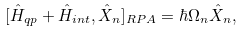Convert formula to latex. <formula><loc_0><loc_0><loc_500><loc_500>[ \hat { H } _ { q p } + \hat { H } _ { i n t } , \hat { X } _ { n } ] _ { R P A } = \hbar { \Omega } _ { n } \hat { X } _ { n } ,</formula> 